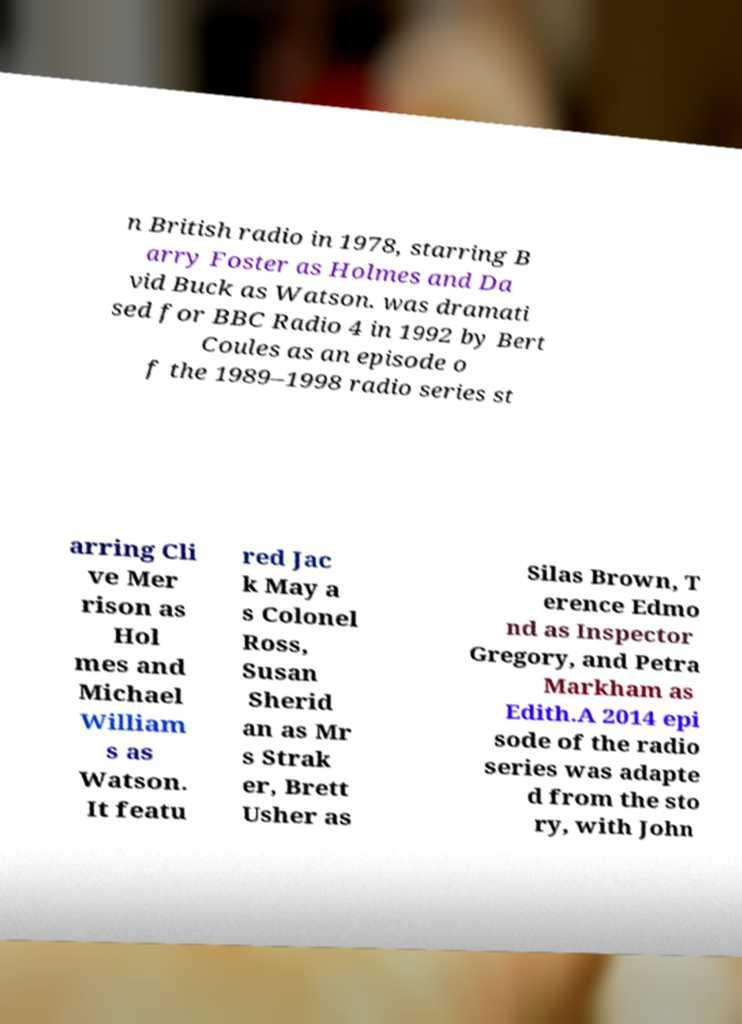What messages or text are displayed in this image? I need them in a readable, typed format. n British radio in 1978, starring B arry Foster as Holmes and Da vid Buck as Watson. was dramati sed for BBC Radio 4 in 1992 by Bert Coules as an episode o f the 1989–1998 radio series st arring Cli ve Mer rison as Hol mes and Michael William s as Watson. It featu red Jac k May a s Colonel Ross, Susan Sherid an as Mr s Strak er, Brett Usher as Silas Brown, T erence Edmo nd as Inspector Gregory, and Petra Markham as Edith.A 2014 epi sode of the radio series was adapte d from the sto ry, with John 